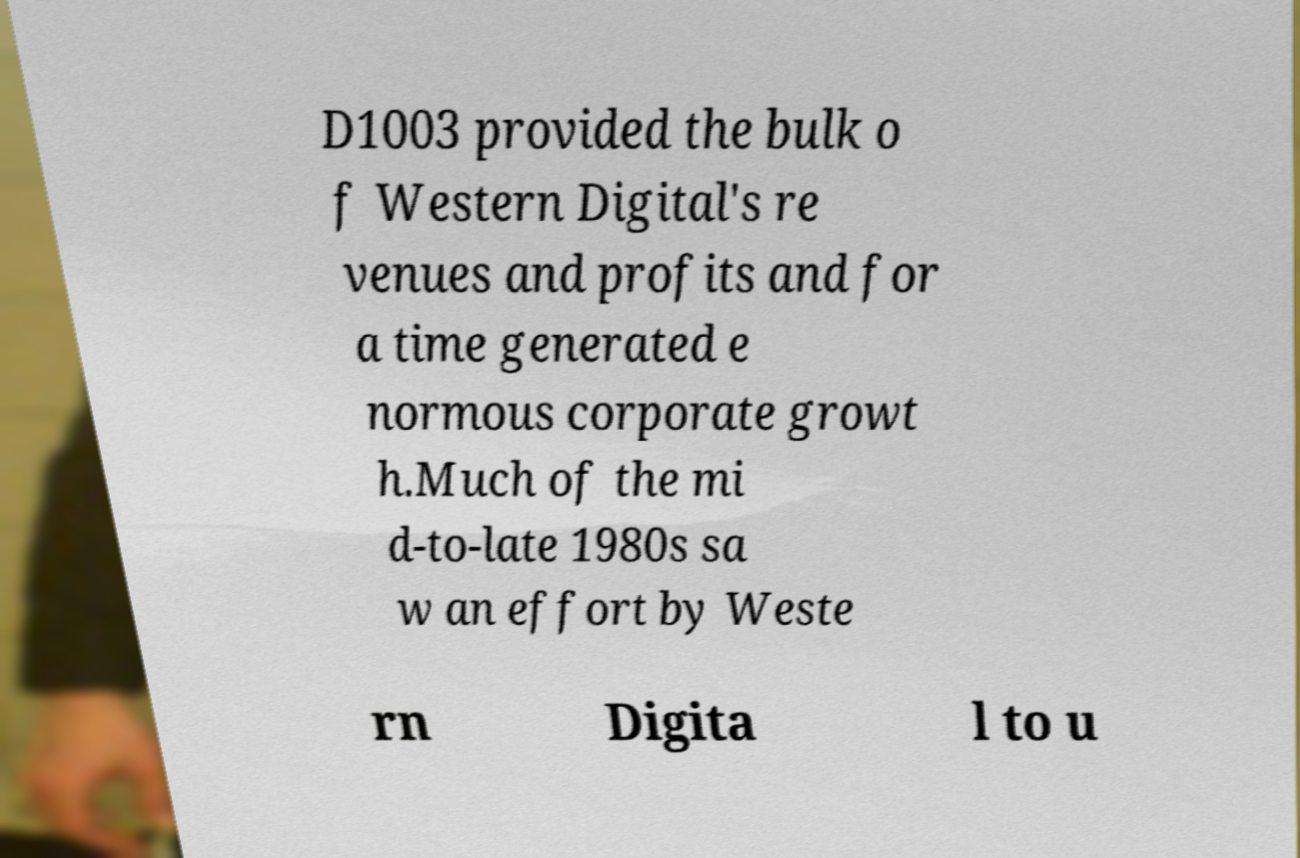Could you extract and type out the text from this image? D1003 provided the bulk o f Western Digital's re venues and profits and for a time generated e normous corporate growt h.Much of the mi d-to-late 1980s sa w an effort by Weste rn Digita l to u 